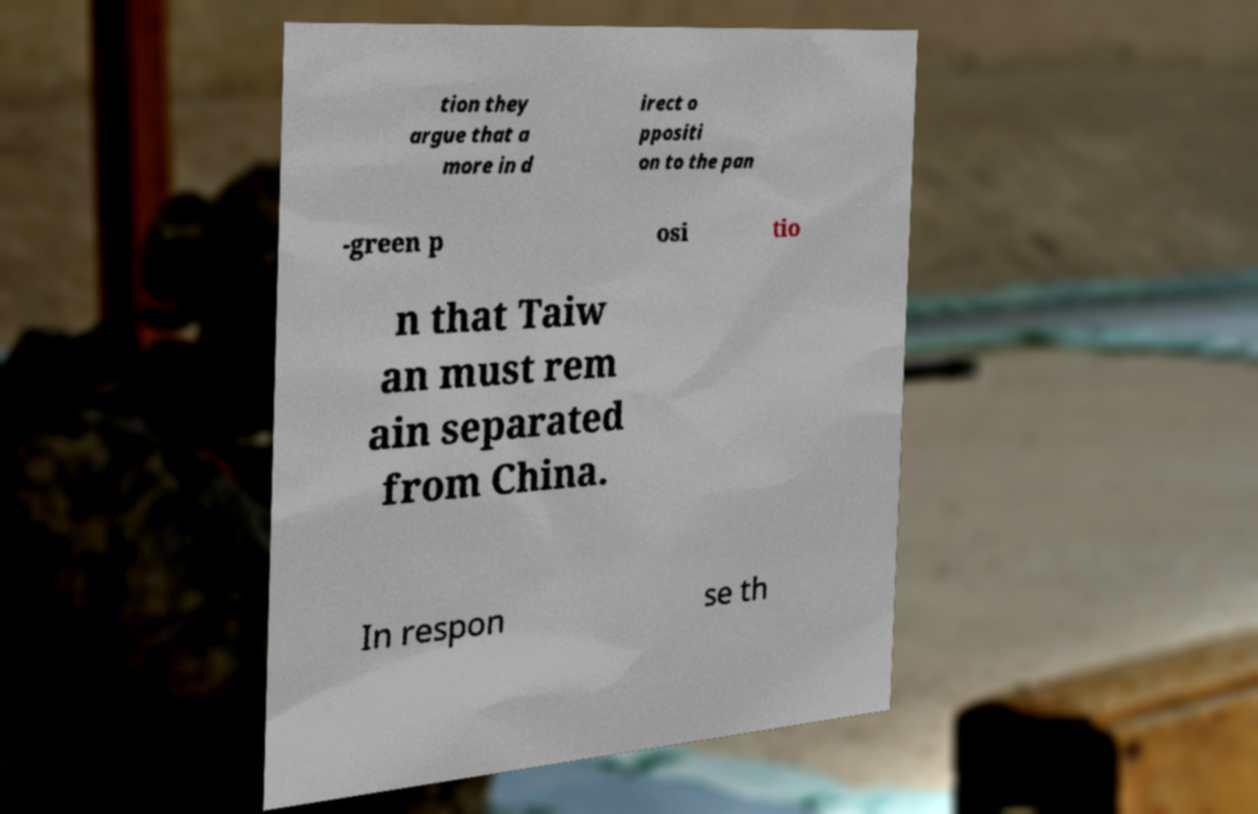Can you read and provide the text displayed in the image?This photo seems to have some interesting text. Can you extract and type it out for me? tion they argue that a more in d irect o ppositi on to the pan -green p osi tio n that Taiw an must rem ain separated from China. In respon se th 